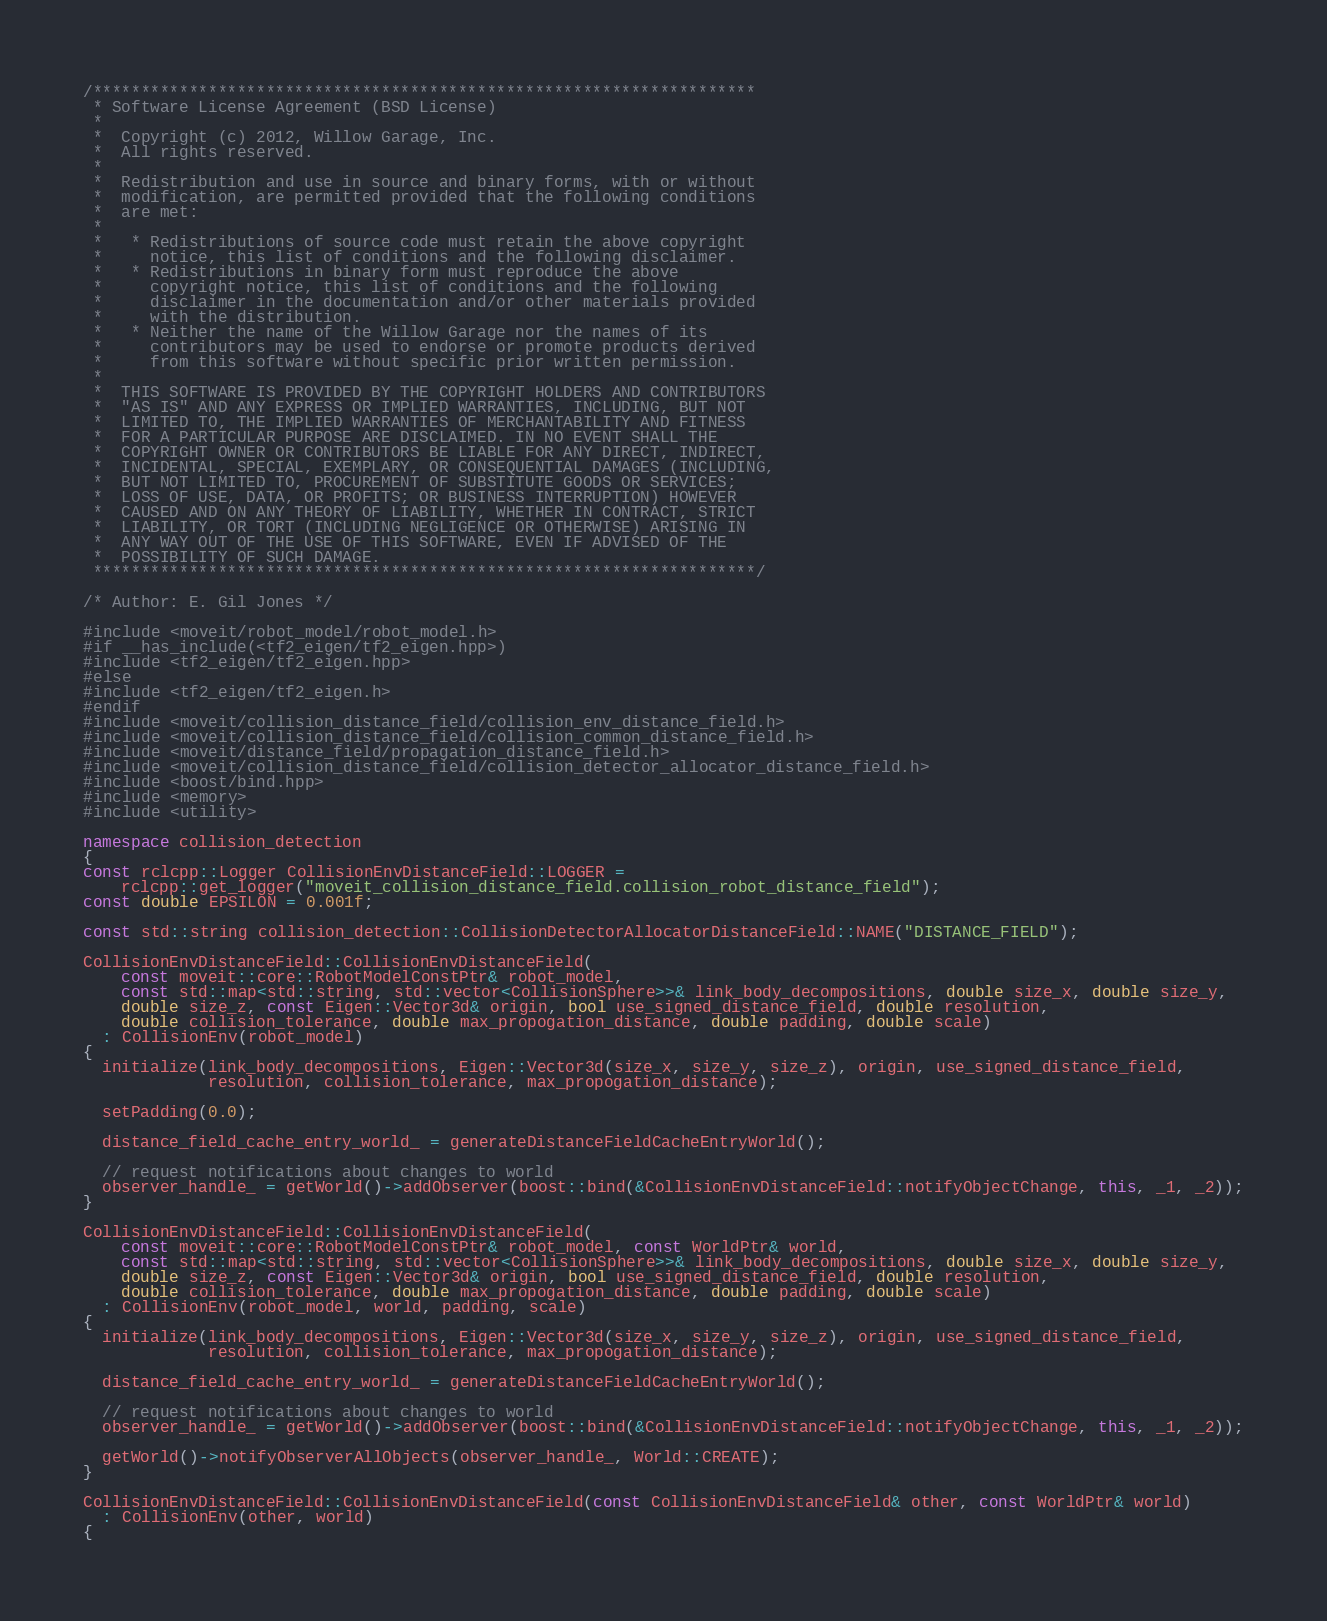Convert code to text. <code><loc_0><loc_0><loc_500><loc_500><_C++_>/*********************************************************************
 * Software License Agreement (BSD License)
 *
 *  Copyright (c) 2012, Willow Garage, Inc.
 *  All rights reserved.
 *
 *  Redistribution and use in source and binary forms, with or without
 *  modification, are permitted provided that the following conditions
 *  are met:
 *
 *   * Redistributions of source code must retain the above copyright
 *     notice, this list of conditions and the following disclaimer.
 *   * Redistributions in binary form must reproduce the above
 *     copyright notice, this list of conditions and the following
 *     disclaimer in the documentation and/or other materials provided
 *     with the distribution.
 *   * Neither the name of the Willow Garage nor the names of its
 *     contributors may be used to endorse or promote products derived
 *     from this software without specific prior written permission.
 *
 *  THIS SOFTWARE IS PROVIDED BY THE COPYRIGHT HOLDERS AND CONTRIBUTORS
 *  "AS IS" AND ANY EXPRESS OR IMPLIED WARRANTIES, INCLUDING, BUT NOT
 *  LIMITED TO, THE IMPLIED WARRANTIES OF MERCHANTABILITY AND FITNESS
 *  FOR A PARTICULAR PURPOSE ARE DISCLAIMED. IN NO EVENT SHALL THE
 *  COPYRIGHT OWNER OR CONTRIBUTORS BE LIABLE FOR ANY DIRECT, INDIRECT,
 *  INCIDENTAL, SPECIAL, EXEMPLARY, OR CONSEQUENTIAL DAMAGES (INCLUDING,
 *  BUT NOT LIMITED TO, PROCUREMENT OF SUBSTITUTE GOODS OR SERVICES;
 *  LOSS OF USE, DATA, OR PROFITS; OR BUSINESS INTERRUPTION) HOWEVER
 *  CAUSED AND ON ANY THEORY OF LIABILITY, WHETHER IN CONTRACT, STRICT
 *  LIABILITY, OR TORT (INCLUDING NEGLIGENCE OR OTHERWISE) ARISING IN
 *  ANY WAY OUT OF THE USE OF THIS SOFTWARE, EVEN IF ADVISED OF THE
 *  POSSIBILITY OF SUCH DAMAGE.
 *********************************************************************/

/* Author: E. Gil Jones */

#include <moveit/robot_model/robot_model.h>
#if __has_include(<tf2_eigen/tf2_eigen.hpp>)
#include <tf2_eigen/tf2_eigen.hpp>
#else
#include <tf2_eigen/tf2_eigen.h>
#endif
#include <moveit/collision_distance_field/collision_env_distance_field.h>
#include <moveit/collision_distance_field/collision_common_distance_field.h>
#include <moveit/distance_field/propagation_distance_field.h>
#include <moveit/collision_distance_field/collision_detector_allocator_distance_field.h>
#include <boost/bind.hpp>
#include <memory>
#include <utility>

namespace collision_detection
{
const rclcpp::Logger CollisionEnvDistanceField::LOGGER =
    rclcpp::get_logger("moveit_collision_distance_field.collision_robot_distance_field");
const double EPSILON = 0.001f;

const std::string collision_detection::CollisionDetectorAllocatorDistanceField::NAME("DISTANCE_FIELD");

CollisionEnvDistanceField::CollisionEnvDistanceField(
    const moveit::core::RobotModelConstPtr& robot_model,
    const std::map<std::string, std::vector<CollisionSphere>>& link_body_decompositions, double size_x, double size_y,
    double size_z, const Eigen::Vector3d& origin, bool use_signed_distance_field, double resolution,
    double collision_tolerance, double max_propogation_distance, double padding, double scale)
  : CollisionEnv(robot_model)
{
  initialize(link_body_decompositions, Eigen::Vector3d(size_x, size_y, size_z), origin, use_signed_distance_field,
             resolution, collision_tolerance, max_propogation_distance);

  setPadding(0.0);

  distance_field_cache_entry_world_ = generateDistanceFieldCacheEntryWorld();

  // request notifications about changes to world
  observer_handle_ = getWorld()->addObserver(boost::bind(&CollisionEnvDistanceField::notifyObjectChange, this, _1, _2));
}

CollisionEnvDistanceField::CollisionEnvDistanceField(
    const moveit::core::RobotModelConstPtr& robot_model, const WorldPtr& world,
    const std::map<std::string, std::vector<CollisionSphere>>& link_body_decompositions, double size_x, double size_y,
    double size_z, const Eigen::Vector3d& origin, bool use_signed_distance_field, double resolution,
    double collision_tolerance, double max_propogation_distance, double padding, double scale)
  : CollisionEnv(robot_model, world, padding, scale)
{
  initialize(link_body_decompositions, Eigen::Vector3d(size_x, size_y, size_z), origin, use_signed_distance_field,
             resolution, collision_tolerance, max_propogation_distance);

  distance_field_cache_entry_world_ = generateDistanceFieldCacheEntryWorld();

  // request notifications about changes to world
  observer_handle_ = getWorld()->addObserver(boost::bind(&CollisionEnvDistanceField::notifyObjectChange, this, _1, _2));

  getWorld()->notifyObserverAllObjects(observer_handle_, World::CREATE);
}

CollisionEnvDistanceField::CollisionEnvDistanceField(const CollisionEnvDistanceField& other, const WorldPtr& world)
  : CollisionEnv(other, world)
{</code> 